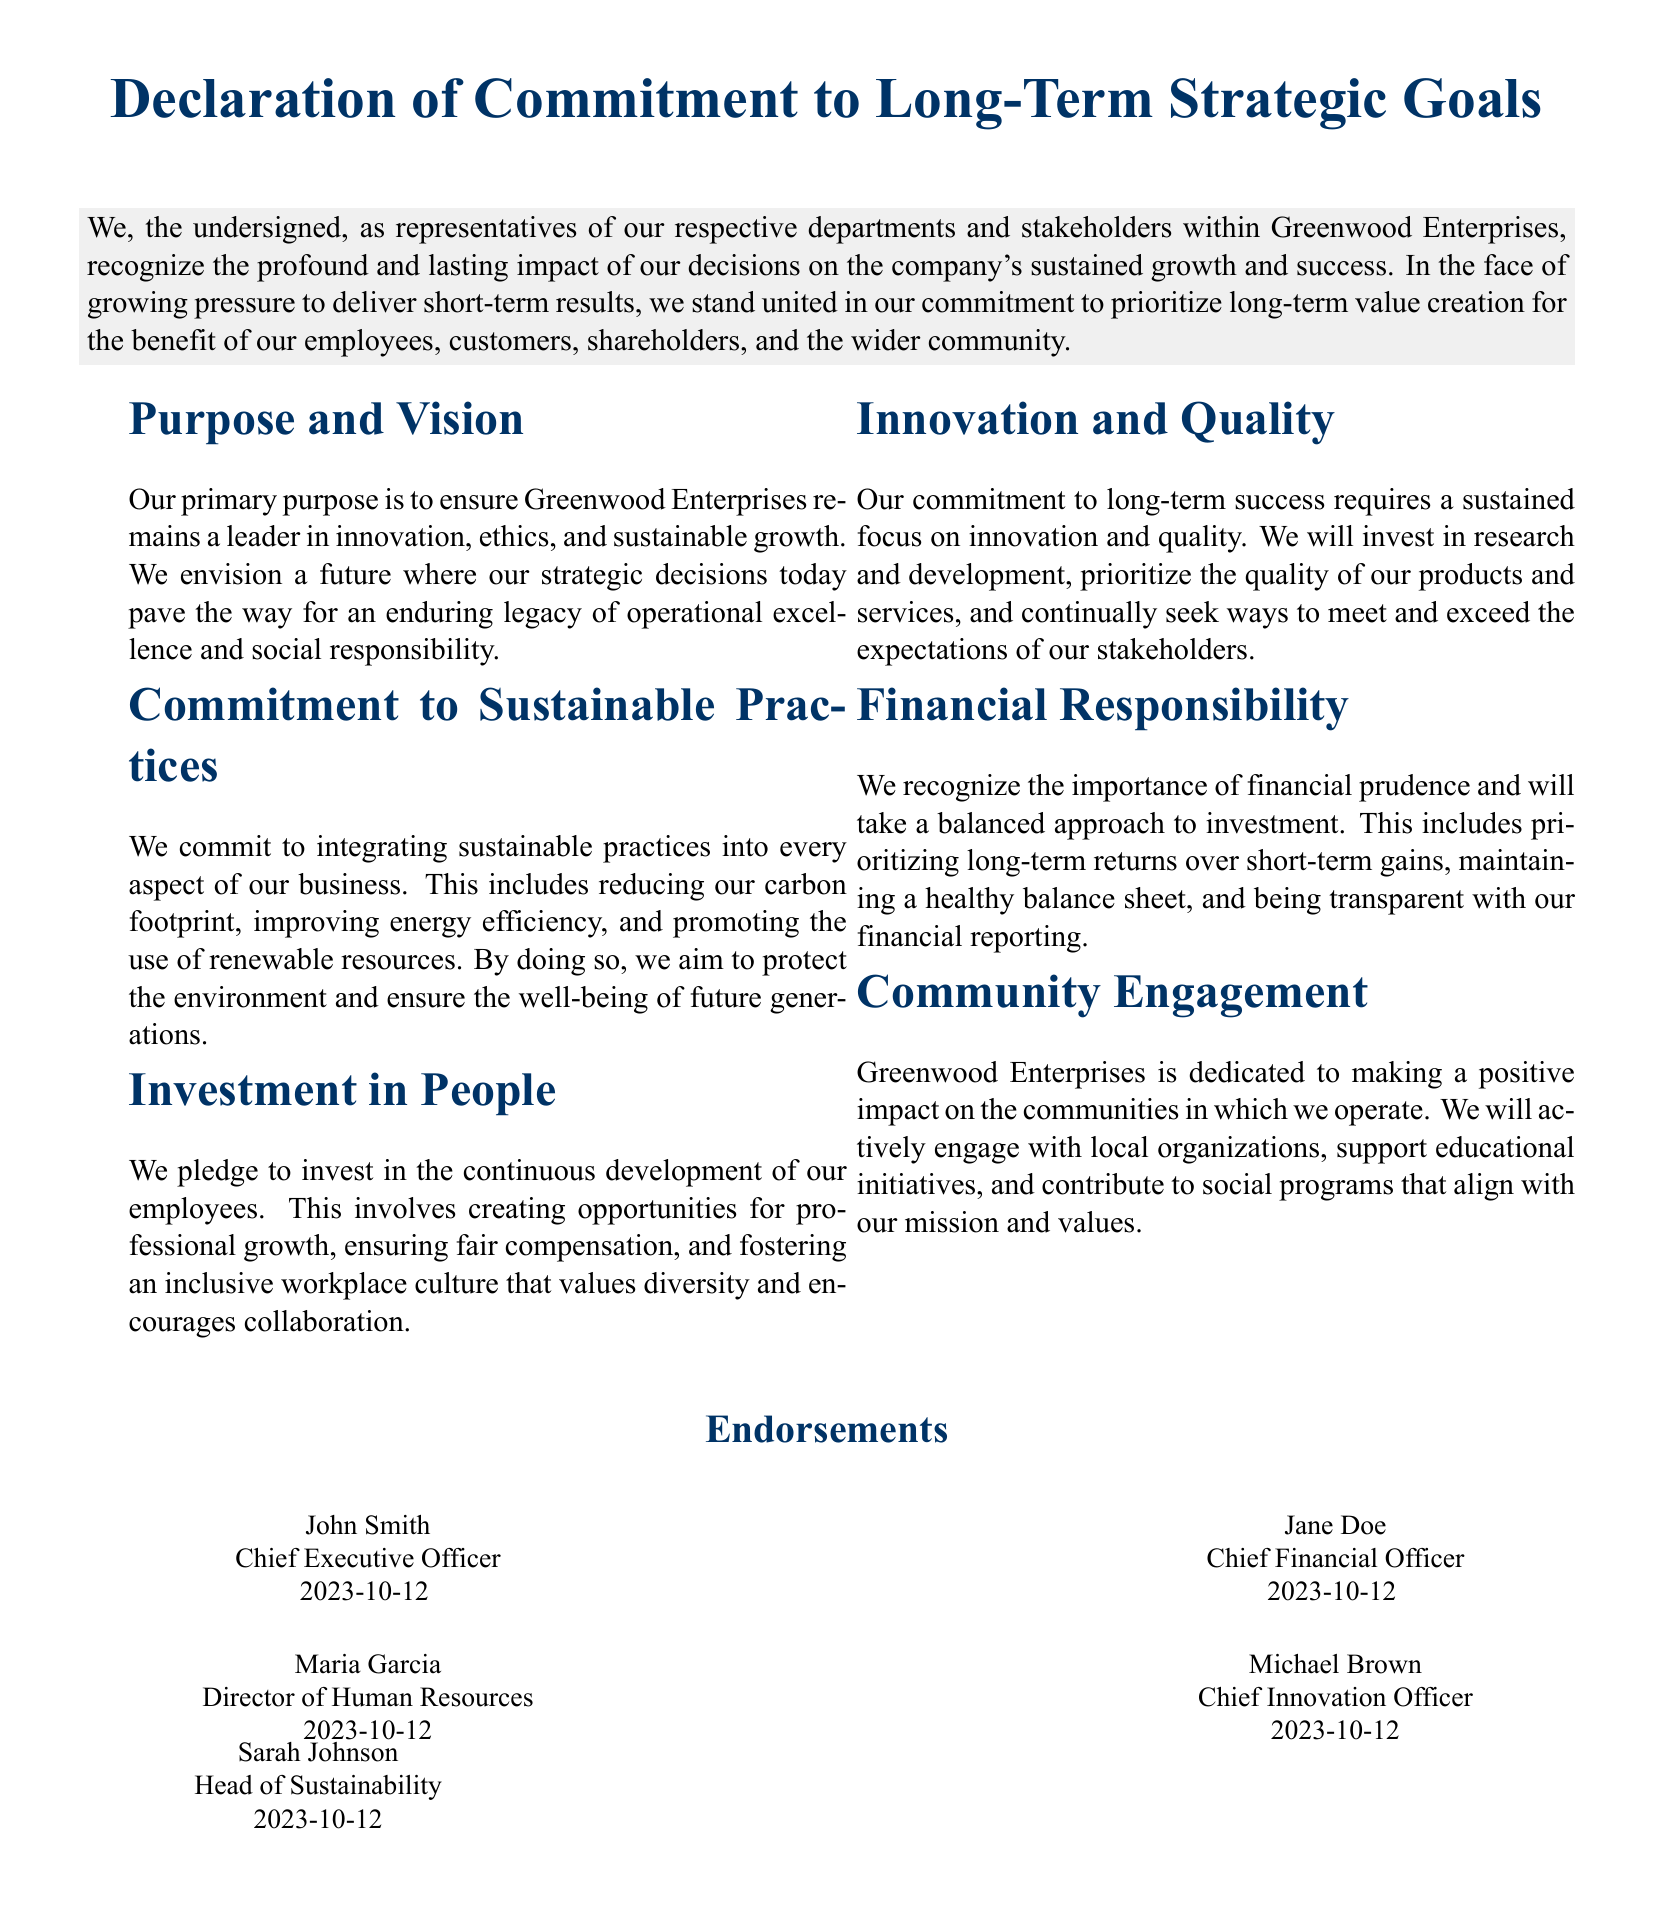what is the title of the document? The title reflects the main theme of the document, which is the commitment to long-term goals.
Answer: Declaration of Commitment to Long-Term Strategic Goals who is the Chief Executive Officer? The CEO is a key stakeholder and endorses the document, providing significant authority to its message.
Answer: John Smith what a section focuses on financial management? This section indicates the commitment to managing finances responsibly for sustainable growth.
Answer: Financial Responsibility how many endorsements are listed in the document? The number of endorsements contributes to the credibility and collective support for the document's objectives.
Answer: Five what is the purpose of the document? This identifies the main goal outlined in the document regarding strategic direction and values.
Answer: Ensure Greenwood Enterprises remains a leader in innovation, ethics, and sustainable growth which aspect emphasizes employee development? This section highlights the organizational commitment to investing in their workforce.
Answer: Investment in People what date was the document signed? The date serves as an important timestamp for the endorsement and commitment expressed by stakeholders.
Answer: 2023-10-12 who is responsible for sustainability? This role emphasizes the organization's focus on environmental and community responsibilities.
Answer: Sarah Johnson what is the vision outlined in the document? This captures the long-term goal for the company's future impact and direction.
Answer: An enduring legacy of operational excellence and social responsibility 